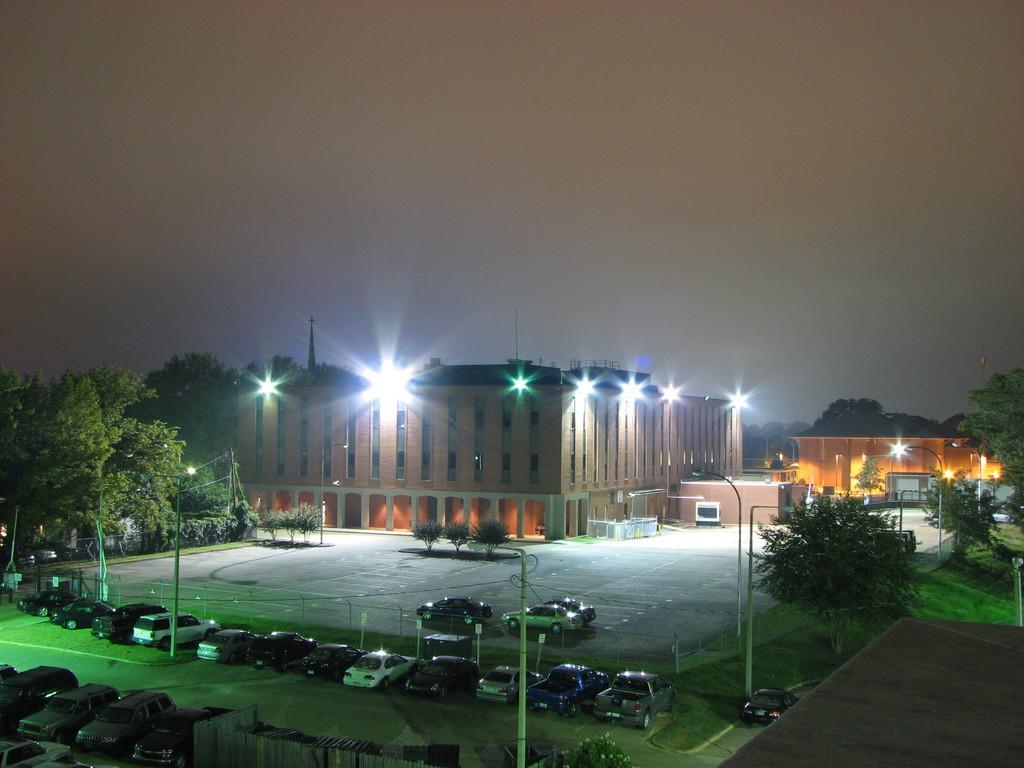In one or two sentences, can you explain what this image depicts? In this image on the foreground there are many cars parked. In the background there are buildings, trees, lights. The sky is clear. 